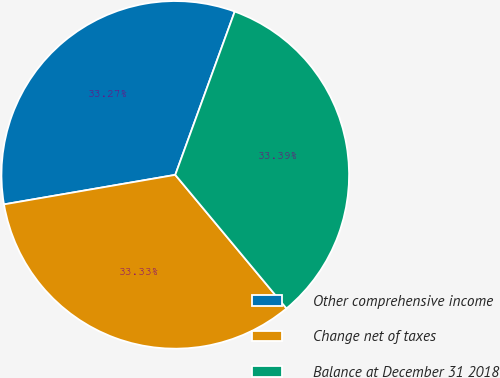<chart> <loc_0><loc_0><loc_500><loc_500><pie_chart><fcel>Other comprehensive income<fcel>Change net of taxes<fcel>Balance at December 31 2018<nl><fcel>33.27%<fcel>33.33%<fcel>33.39%<nl></chart> 